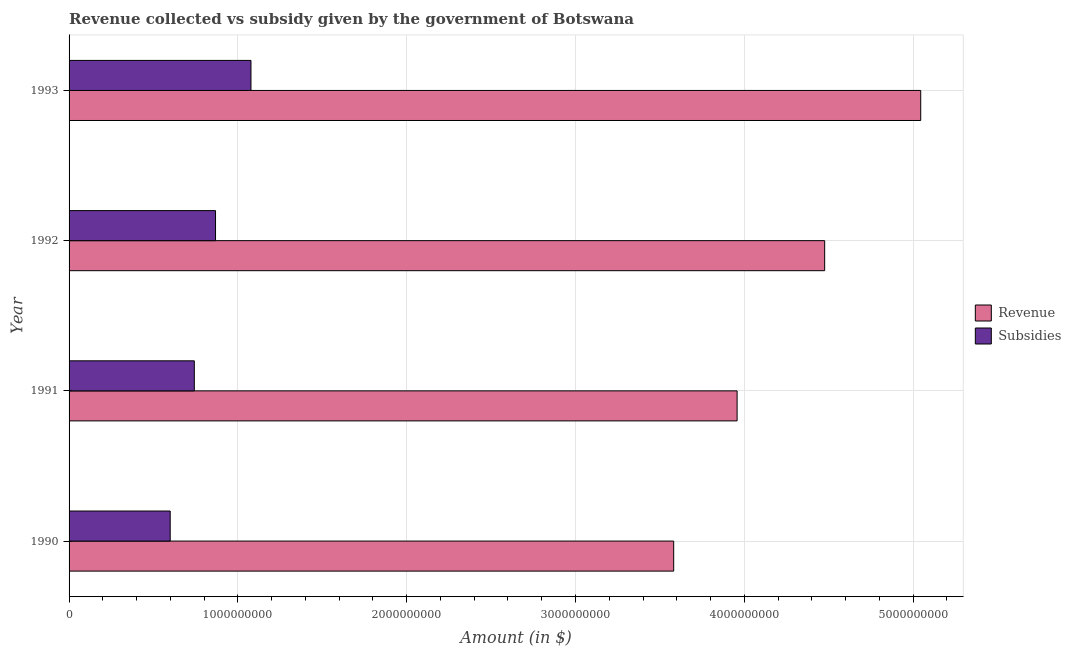How many different coloured bars are there?
Ensure brevity in your answer.  2. How many bars are there on the 1st tick from the top?
Give a very brief answer. 2. How many bars are there on the 1st tick from the bottom?
Provide a short and direct response. 2. In how many cases, is the number of bars for a given year not equal to the number of legend labels?
Keep it short and to the point. 0. What is the amount of subsidies given in 1991?
Your answer should be very brief. 7.42e+08. Across all years, what is the maximum amount of subsidies given?
Give a very brief answer. 1.08e+09. Across all years, what is the minimum amount of subsidies given?
Your answer should be very brief. 5.99e+08. In which year was the amount of subsidies given minimum?
Your response must be concise. 1990. What is the total amount of revenue collected in the graph?
Provide a succinct answer. 1.71e+1. What is the difference between the amount of subsidies given in 1990 and that in 1993?
Offer a terse response. -4.78e+08. What is the difference between the amount of revenue collected in 1990 and the amount of subsidies given in 1992?
Your answer should be very brief. 2.71e+09. What is the average amount of revenue collected per year?
Provide a short and direct response. 4.27e+09. In the year 1992, what is the difference between the amount of revenue collected and amount of subsidies given?
Your answer should be very brief. 3.61e+09. In how many years, is the amount of revenue collected greater than 4200000000 $?
Offer a very short reply. 2. What is the ratio of the amount of revenue collected in 1992 to that in 1993?
Your answer should be very brief. 0.89. Is the amount of revenue collected in 1990 less than that in 1992?
Ensure brevity in your answer.  Yes. What is the difference between the highest and the second highest amount of subsidies given?
Your response must be concise. 2.10e+08. What is the difference between the highest and the lowest amount of subsidies given?
Your response must be concise. 4.78e+08. In how many years, is the amount of revenue collected greater than the average amount of revenue collected taken over all years?
Give a very brief answer. 2. Is the sum of the amount of revenue collected in 1991 and 1993 greater than the maximum amount of subsidies given across all years?
Give a very brief answer. Yes. What does the 1st bar from the top in 1993 represents?
Offer a terse response. Subsidies. What does the 1st bar from the bottom in 1993 represents?
Your response must be concise. Revenue. Are all the bars in the graph horizontal?
Your answer should be compact. Yes. What is the difference between two consecutive major ticks on the X-axis?
Your answer should be compact. 1.00e+09. Are the values on the major ticks of X-axis written in scientific E-notation?
Provide a succinct answer. No. Does the graph contain any zero values?
Offer a terse response. No. How many legend labels are there?
Keep it short and to the point. 2. What is the title of the graph?
Your answer should be very brief. Revenue collected vs subsidy given by the government of Botswana. What is the label or title of the X-axis?
Provide a succinct answer. Amount (in $). What is the Amount (in $) in Revenue in 1990?
Your answer should be compact. 3.58e+09. What is the Amount (in $) of Subsidies in 1990?
Give a very brief answer. 5.99e+08. What is the Amount (in $) of Revenue in 1991?
Offer a terse response. 3.96e+09. What is the Amount (in $) in Subsidies in 1991?
Offer a terse response. 7.42e+08. What is the Amount (in $) of Revenue in 1992?
Keep it short and to the point. 4.48e+09. What is the Amount (in $) in Subsidies in 1992?
Offer a very short reply. 8.68e+08. What is the Amount (in $) of Revenue in 1993?
Your answer should be very brief. 5.05e+09. What is the Amount (in $) in Subsidies in 1993?
Your answer should be compact. 1.08e+09. Across all years, what is the maximum Amount (in $) in Revenue?
Your answer should be compact. 5.05e+09. Across all years, what is the maximum Amount (in $) of Subsidies?
Keep it short and to the point. 1.08e+09. Across all years, what is the minimum Amount (in $) of Revenue?
Your answer should be very brief. 3.58e+09. Across all years, what is the minimum Amount (in $) of Subsidies?
Offer a very short reply. 5.99e+08. What is the total Amount (in $) in Revenue in the graph?
Provide a short and direct response. 1.71e+1. What is the total Amount (in $) of Subsidies in the graph?
Make the answer very short. 3.29e+09. What is the difference between the Amount (in $) in Revenue in 1990 and that in 1991?
Ensure brevity in your answer.  -3.76e+08. What is the difference between the Amount (in $) in Subsidies in 1990 and that in 1991?
Give a very brief answer. -1.43e+08. What is the difference between the Amount (in $) in Revenue in 1990 and that in 1992?
Keep it short and to the point. -8.94e+08. What is the difference between the Amount (in $) in Subsidies in 1990 and that in 1992?
Offer a very short reply. -2.68e+08. What is the difference between the Amount (in $) in Revenue in 1990 and that in 1993?
Provide a succinct answer. -1.46e+09. What is the difference between the Amount (in $) in Subsidies in 1990 and that in 1993?
Your response must be concise. -4.78e+08. What is the difference between the Amount (in $) of Revenue in 1991 and that in 1992?
Offer a terse response. -5.19e+08. What is the difference between the Amount (in $) in Subsidies in 1991 and that in 1992?
Provide a succinct answer. -1.26e+08. What is the difference between the Amount (in $) of Revenue in 1991 and that in 1993?
Provide a succinct answer. -1.09e+09. What is the difference between the Amount (in $) in Subsidies in 1991 and that in 1993?
Give a very brief answer. -3.36e+08. What is the difference between the Amount (in $) of Revenue in 1992 and that in 1993?
Provide a short and direct response. -5.69e+08. What is the difference between the Amount (in $) in Subsidies in 1992 and that in 1993?
Your answer should be very brief. -2.10e+08. What is the difference between the Amount (in $) in Revenue in 1990 and the Amount (in $) in Subsidies in 1991?
Your response must be concise. 2.84e+09. What is the difference between the Amount (in $) of Revenue in 1990 and the Amount (in $) of Subsidies in 1992?
Your answer should be compact. 2.71e+09. What is the difference between the Amount (in $) of Revenue in 1990 and the Amount (in $) of Subsidies in 1993?
Your answer should be very brief. 2.50e+09. What is the difference between the Amount (in $) in Revenue in 1991 and the Amount (in $) in Subsidies in 1992?
Offer a terse response. 3.09e+09. What is the difference between the Amount (in $) in Revenue in 1991 and the Amount (in $) in Subsidies in 1993?
Your answer should be very brief. 2.88e+09. What is the difference between the Amount (in $) in Revenue in 1992 and the Amount (in $) in Subsidies in 1993?
Provide a succinct answer. 3.40e+09. What is the average Amount (in $) of Revenue per year?
Your response must be concise. 4.27e+09. What is the average Amount (in $) in Subsidies per year?
Provide a succinct answer. 8.22e+08. In the year 1990, what is the difference between the Amount (in $) of Revenue and Amount (in $) of Subsidies?
Your answer should be very brief. 2.98e+09. In the year 1991, what is the difference between the Amount (in $) of Revenue and Amount (in $) of Subsidies?
Provide a succinct answer. 3.22e+09. In the year 1992, what is the difference between the Amount (in $) in Revenue and Amount (in $) in Subsidies?
Your answer should be compact. 3.61e+09. In the year 1993, what is the difference between the Amount (in $) of Revenue and Amount (in $) of Subsidies?
Your answer should be very brief. 3.97e+09. What is the ratio of the Amount (in $) in Revenue in 1990 to that in 1991?
Provide a short and direct response. 0.91. What is the ratio of the Amount (in $) in Subsidies in 1990 to that in 1991?
Keep it short and to the point. 0.81. What is the ratio of the Amount (in $) in Revenue in 1990 to that in 1992?
Offer a very short reply. 0.8. What is the ratio of the Amount (in $) in Subsidies in 1990 to that in 1992?
Provide a short and direct response. 0.69. What is the ratio of the Amount (in $) of Revenue in 1990 to that in 1993?
Provide a succinct answer. 0.71. What is the ratio of the Amount (in $) of Subsidies in 1990 to that in 1993?
Provide a short and direct response. 0.56. What is the ratio of the Amount (in $) in Revenue in 1991 to that in 1992?
Keep it short and to the point. 0.88. What is the ratio of the Amount (in $) in Subsidies in 1991 to that in 1992?
Give a very brief answer. 0.86. What is the ratio of the Amount (in $) in Revenue in 1991 to that in 1993?
Provide a short and direct response. 0.78. What is the ratio of the Amount (in $) in Subsidies in 1991 to that in 1993?
Keep it short and to the point. 0.69. What is the ratio of the Amount (in $) of Revenue in 1992 to that in 1993?
Give a very brief answer. 0.89. What is the ratio of the Amount (in $) of Subsidies in 1992 to that in 1993?
Keep it short and to the point. 0.81. What is the difference between the highest and the second highest Amount (in $) of Revenue?
Provide a succinct answer. 5.69e+08. What is the difference between the highest and the second highest Amount (in $) of Subsidies?
Offer a very short reply. 2.10e+08. What is the difference between the highest and the lowest Amount (in $) in Revenue?
Your answer should be very brief. 1.46e+09. What is the difference between the highest and the lowest Amount (in $) of Subsidies?
Make the answer very short. 4.78e+08. 